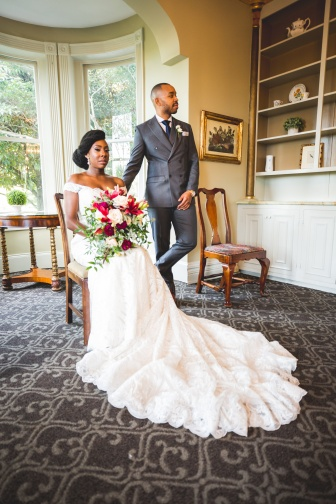Describe the following image.
 In the image, a bride and groom are captured in a moment of quiet intimacy. The bride, adorned in a white dress with a long train, is seated on a wooden chair. A bouquet of flowers rests in her lap, adding a touch of color to her ensemble. Standing next to her, the groom, dressed in a gray suit, gazes at his bride. 

The room they are in is simple yet elegant. A large window allows natural light to fill the space, casting a soft glow on the couple. A bookcase stands nearby, a vase of flowers perched on top. The walls are painted white, contrasting with the gray carpet underfoot. A painting hangs on the wall, adding a touch of artistry to the room. 

The positioning of the couple and their surroundings suggests a moment of calm before or after the wedding ceremony. The groom's attention is focused on the bride, while she appears to be lost in thought. The image captures a snapshot of their special day, a moment frozen in time for them to look back on. 